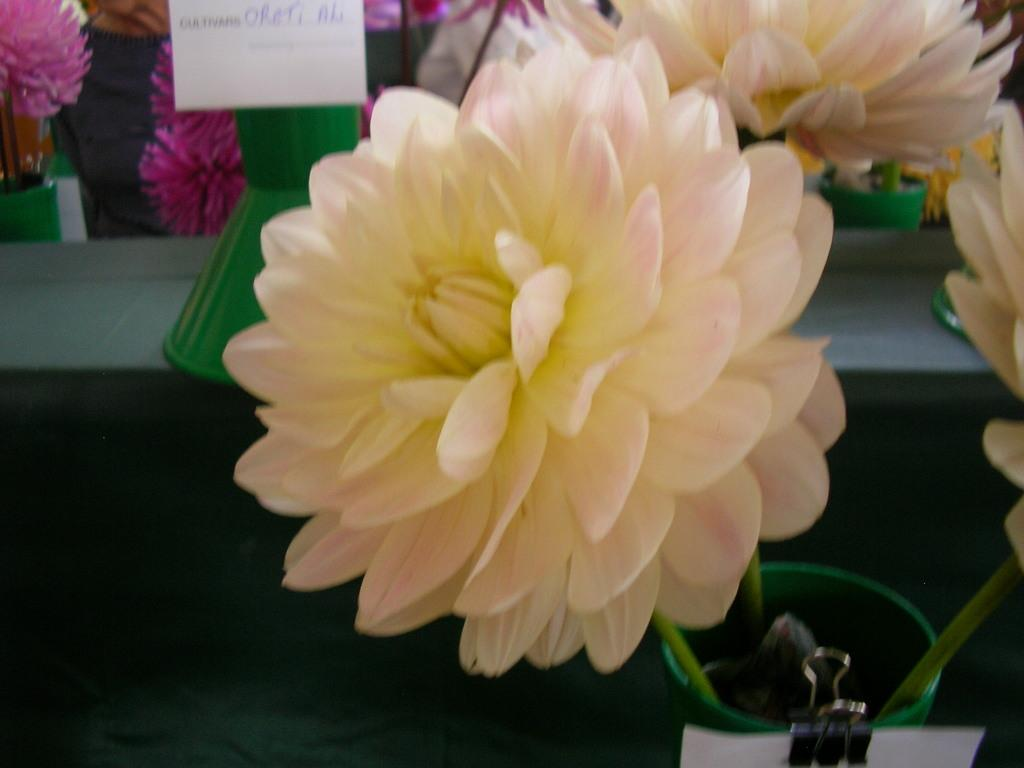What type of objects can be seen in the image? There are flowers and a white paper in the image. Can you describe the flowers in the image? The flowers are in cream and pink colors. What is the color of the pot in the image? The pot in the image is green. What is written on the white paper? Unfortunately, the specific content of the writing cannot be determined from the image. Can you see a watch on the flowers in the image? No, there is no watch present on the flowers in the image. Is the moon visible in the image? No, the moon is not visible in the image. 